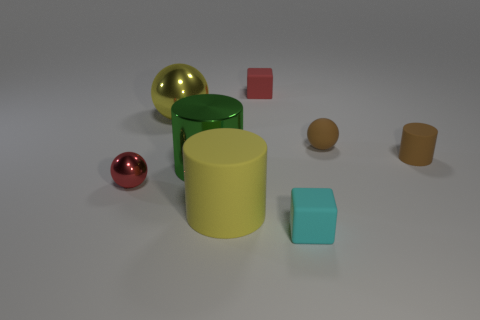What color is the small matte object in front of the tiny metallic sphere?
Provide a short and direct response. Cyan. There is a big thing in front of the red ball; is its shape the same as the big shiny thing behind the brown rubber ball?
Provide a succinct answer. No. Are there any red matte objects that have the same size as the brown rubber cylinder?
Provide a succinct answer. Yes. What material is the red thing that is behind the tiny brown rubber cylinder?
Offer a very short reply. Rubber. Is the yellow object that is on the right side of the big green shiny thing made of the same material as the large green object?
Your answer should be very brief. No. Are any red metal spheres visible?
Provide a succinct answer. Yes. The small cylinder that is made of the same material as the cyan thing is what color?
Keep it short and to the point. Brown. What is the color of the tiny block that is in front of the shiny sphere that is behind the tiny sphere that is on the left side of the big yellow sphere?
Offer a terse response. Cyan. There is a rubber sphere; is it the same size as the rubber cylinder on the left side of the brown cylinder?
Keep it short and to the point. No. How many things are blocks in front of the yellow metal sphere or small brown matte cylinders that are in front of the yellow shiny object?
Give a very brief answer. 2. 